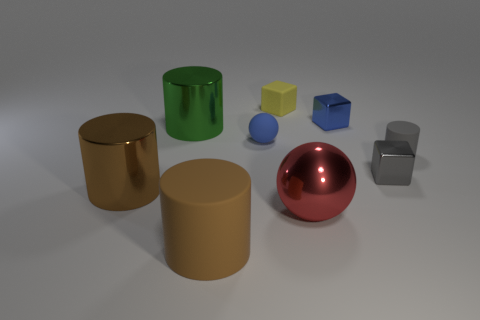There is a big metallic thing left of the green shiny cylinder; is its shape the same as the tiny matte thing that is to the right of the small blue metallic cube?
Your response must be concise. Yes. What is the color of the big cylinder that is made of the same material as the small yellow cube?
Your response must be concise. Brown. There is a ball that is to the right of the yellow matte thing; does it have the same size as the rubber cylinder that is left of the yellow rubber thing?
Provide a succinct answer. Yes. The object that is both in front of the small gray rubber cylinder and to the right of the small blue metal thing has what shape?
Offer a very short reply. Cube. Are there any other green cylinders that have the same material as the small cylinder?
Give a very brief answer. No. Are the big cylinder behind the tiny gray cube and the large brown thing that is left of the large brown matte object made of the same material?
Ensure brevity in your answer.  Yes. Is the number of rubber objects greater than the number of tiny gray shiny cubes?
Keep it short and to the point. Yes. There is a big metallic cylinder that is behind the big brown thing behind the big thing that is on the right side of the rubber sphere; what is its color?
Ensure brevity in your answer.  Green. There is a metallic cylinder in front of the small gray matte cylinder; is it the same color as the small block that is to the left of the big shiny ball?
Provide a short and direct response. No. How many tiny shiny things are to the left of the big shiny sphere left of the small blue metallic object?
Make the answer very short. 0. 